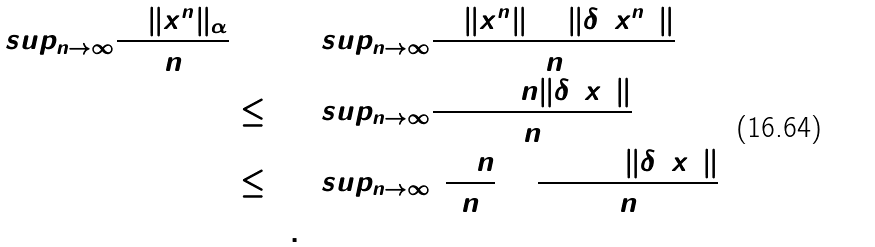<formula> <loc_0><loc_0><loc_500><loc_500>\lim s u p _ { n \rightarrow \infty } \frac { \ln \| x ^ { n } \| _ { \alpha } } { n } & = \lim s u p _ { n \rightarrow \infty } \frac { \ln \| x ^ { n } \| + \| \delta ( x ^ { n } ) \| } { n } \\ & \leq \lim s u p _ { n \rightarrow \infty } \frac { \ln 1 + n \| \delta ( x ) \| } { n } \\ & \leq \lim s u p _ { n \rightarrow \infty } ( \frac { \ln n } { n } + \frac { \ln 1 + \| \delta ( x ) \| } { n } ) \\ & = 0 .</formula> 